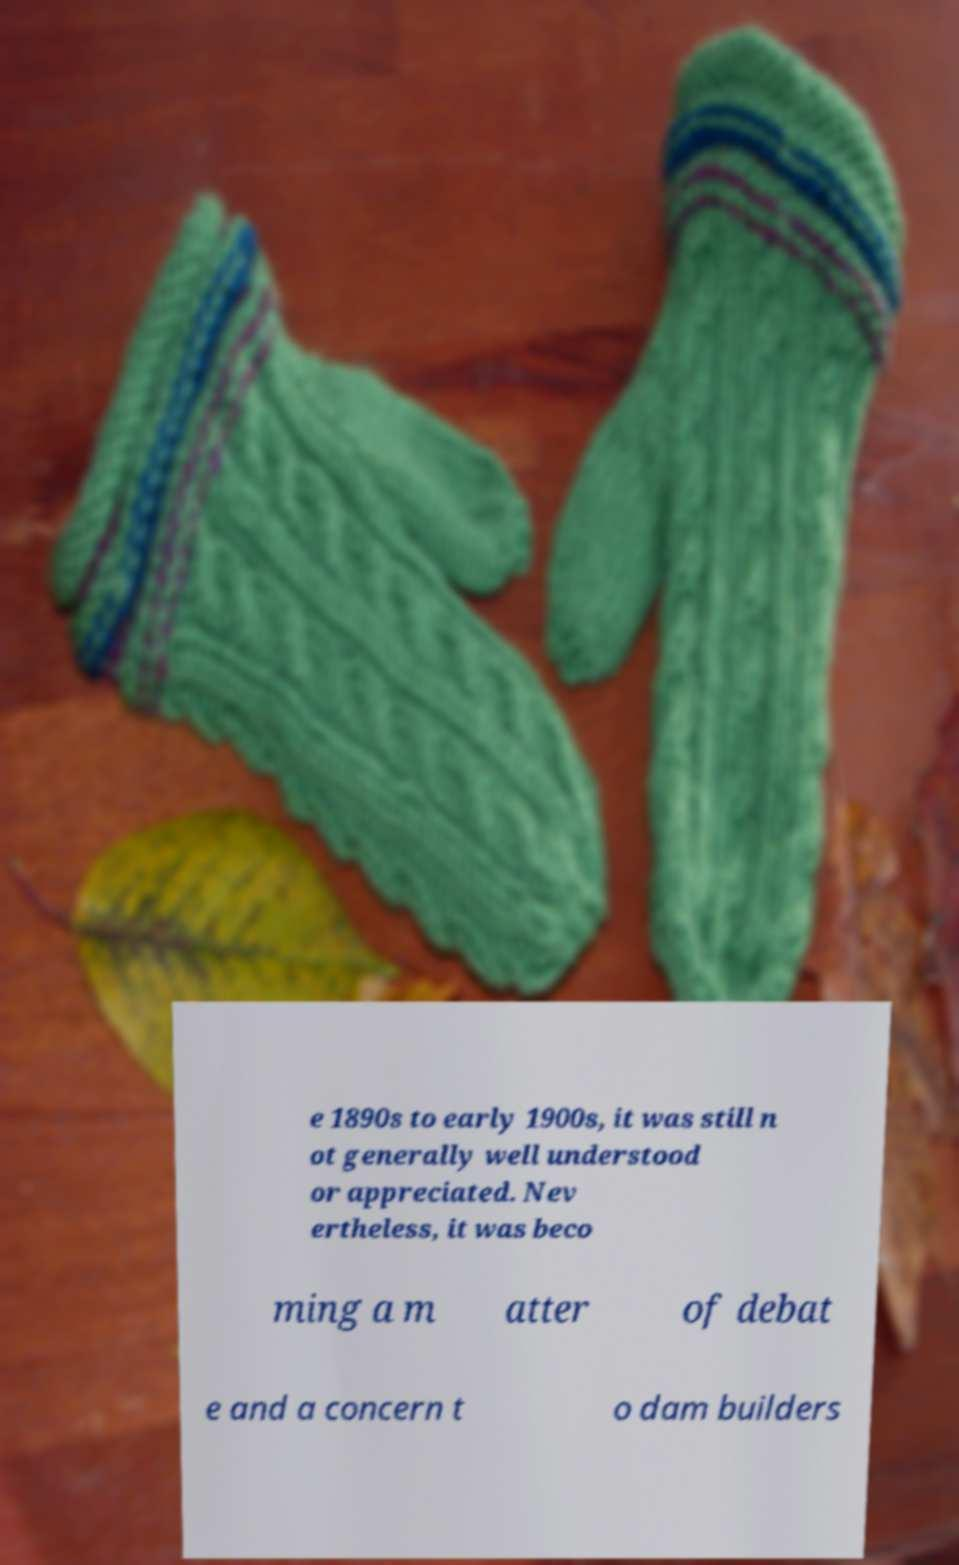Can you accurately transcribe the text from the provided image for me? e 1890s to early 1900s, it was still n ot generally well understood or appreciated. Nev ertheless, it was beco ming a m atter of debat e and a concern t o dam builders 